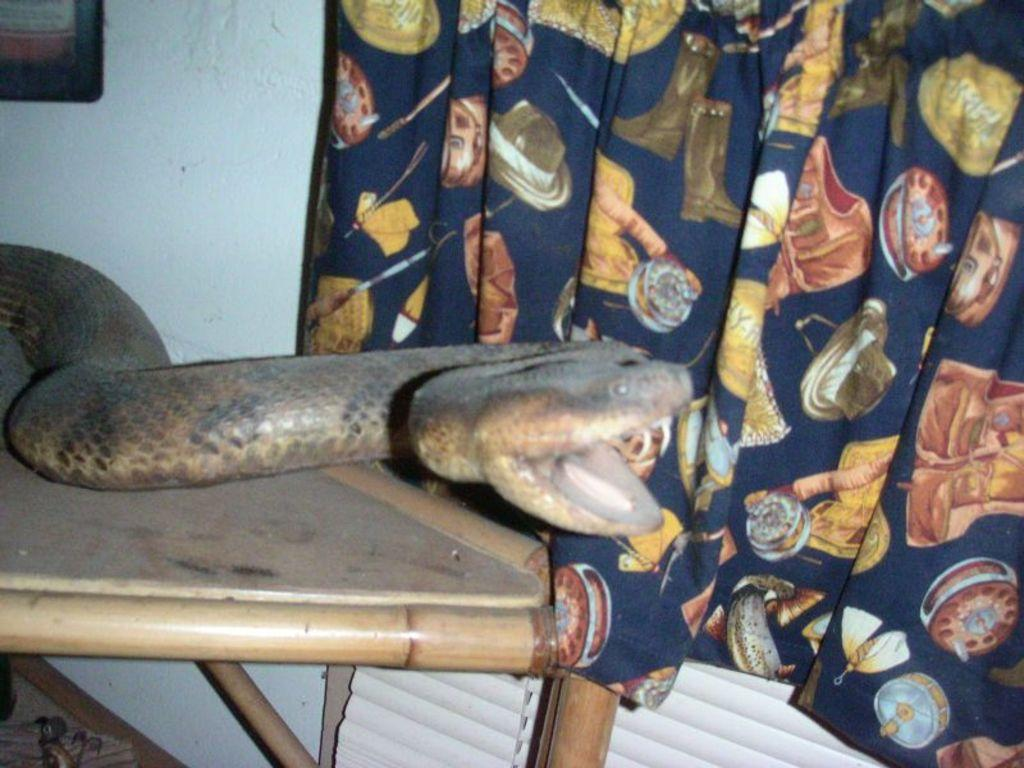What type of animal is in the image? There is a snake in the image. What is the primary object on which the snake is resting? There is a wooden table in the image. What is the background of the image made of? There is a wall in the image. What type of window treatment is present in the image? There are curtains in the image. What surface is visible beneath the snake and table? There is a floor visible in the image. What type of cloth is the goose wearing in the image? There is no goose present in the image, and therefore no cloth or clothing to describe. 